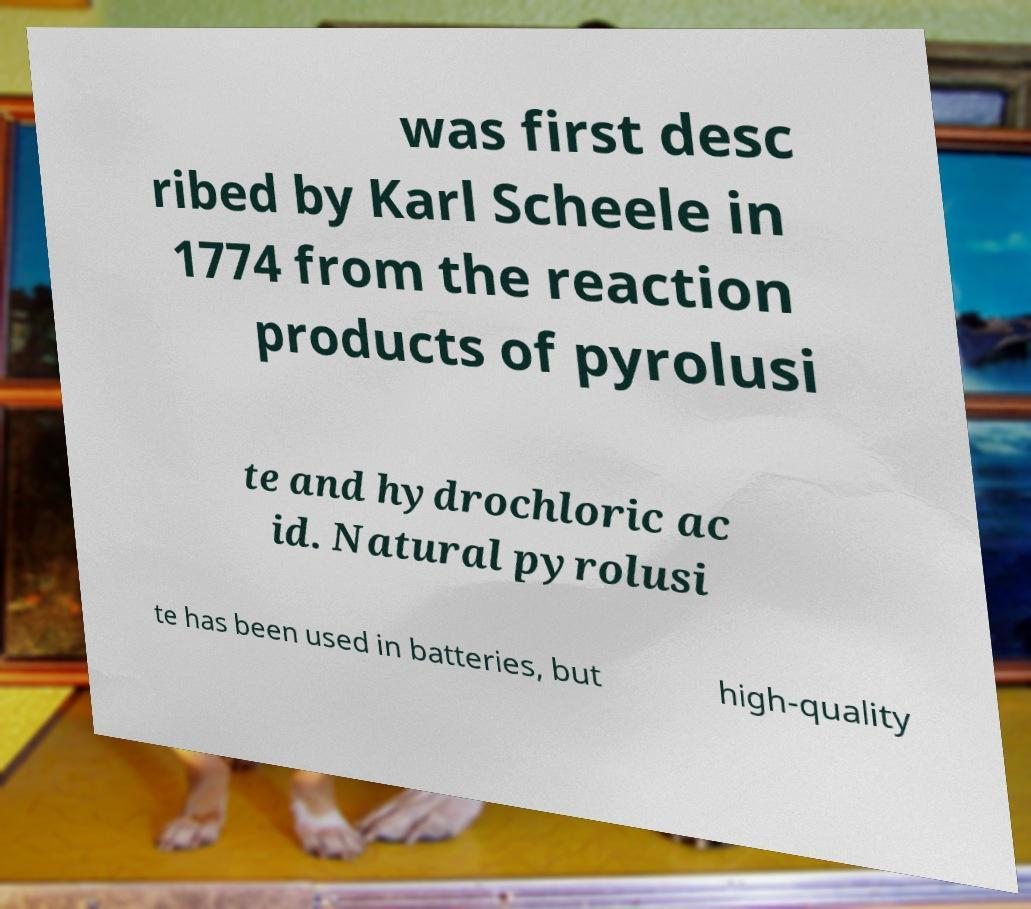Please identify and transcribe the text found in this image. was first desc ribed by Karl Scheele in 1774 from the reaction products of pyrolusi te and hydrochloric ac id. Natural pyrolusi te has been used in batteries, but high-quality 